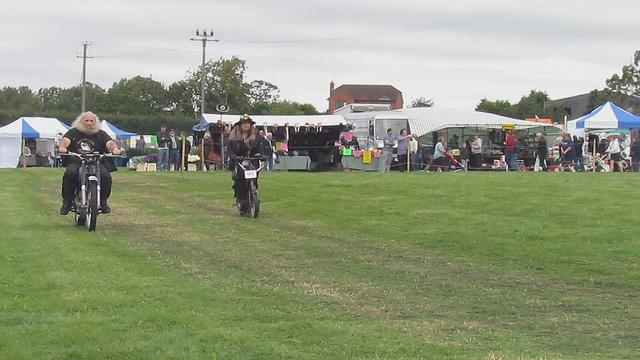What type food is more likely served here?

Choices:
A) salads
B) filet mignon
C) hot dog
D) chile hot dog 